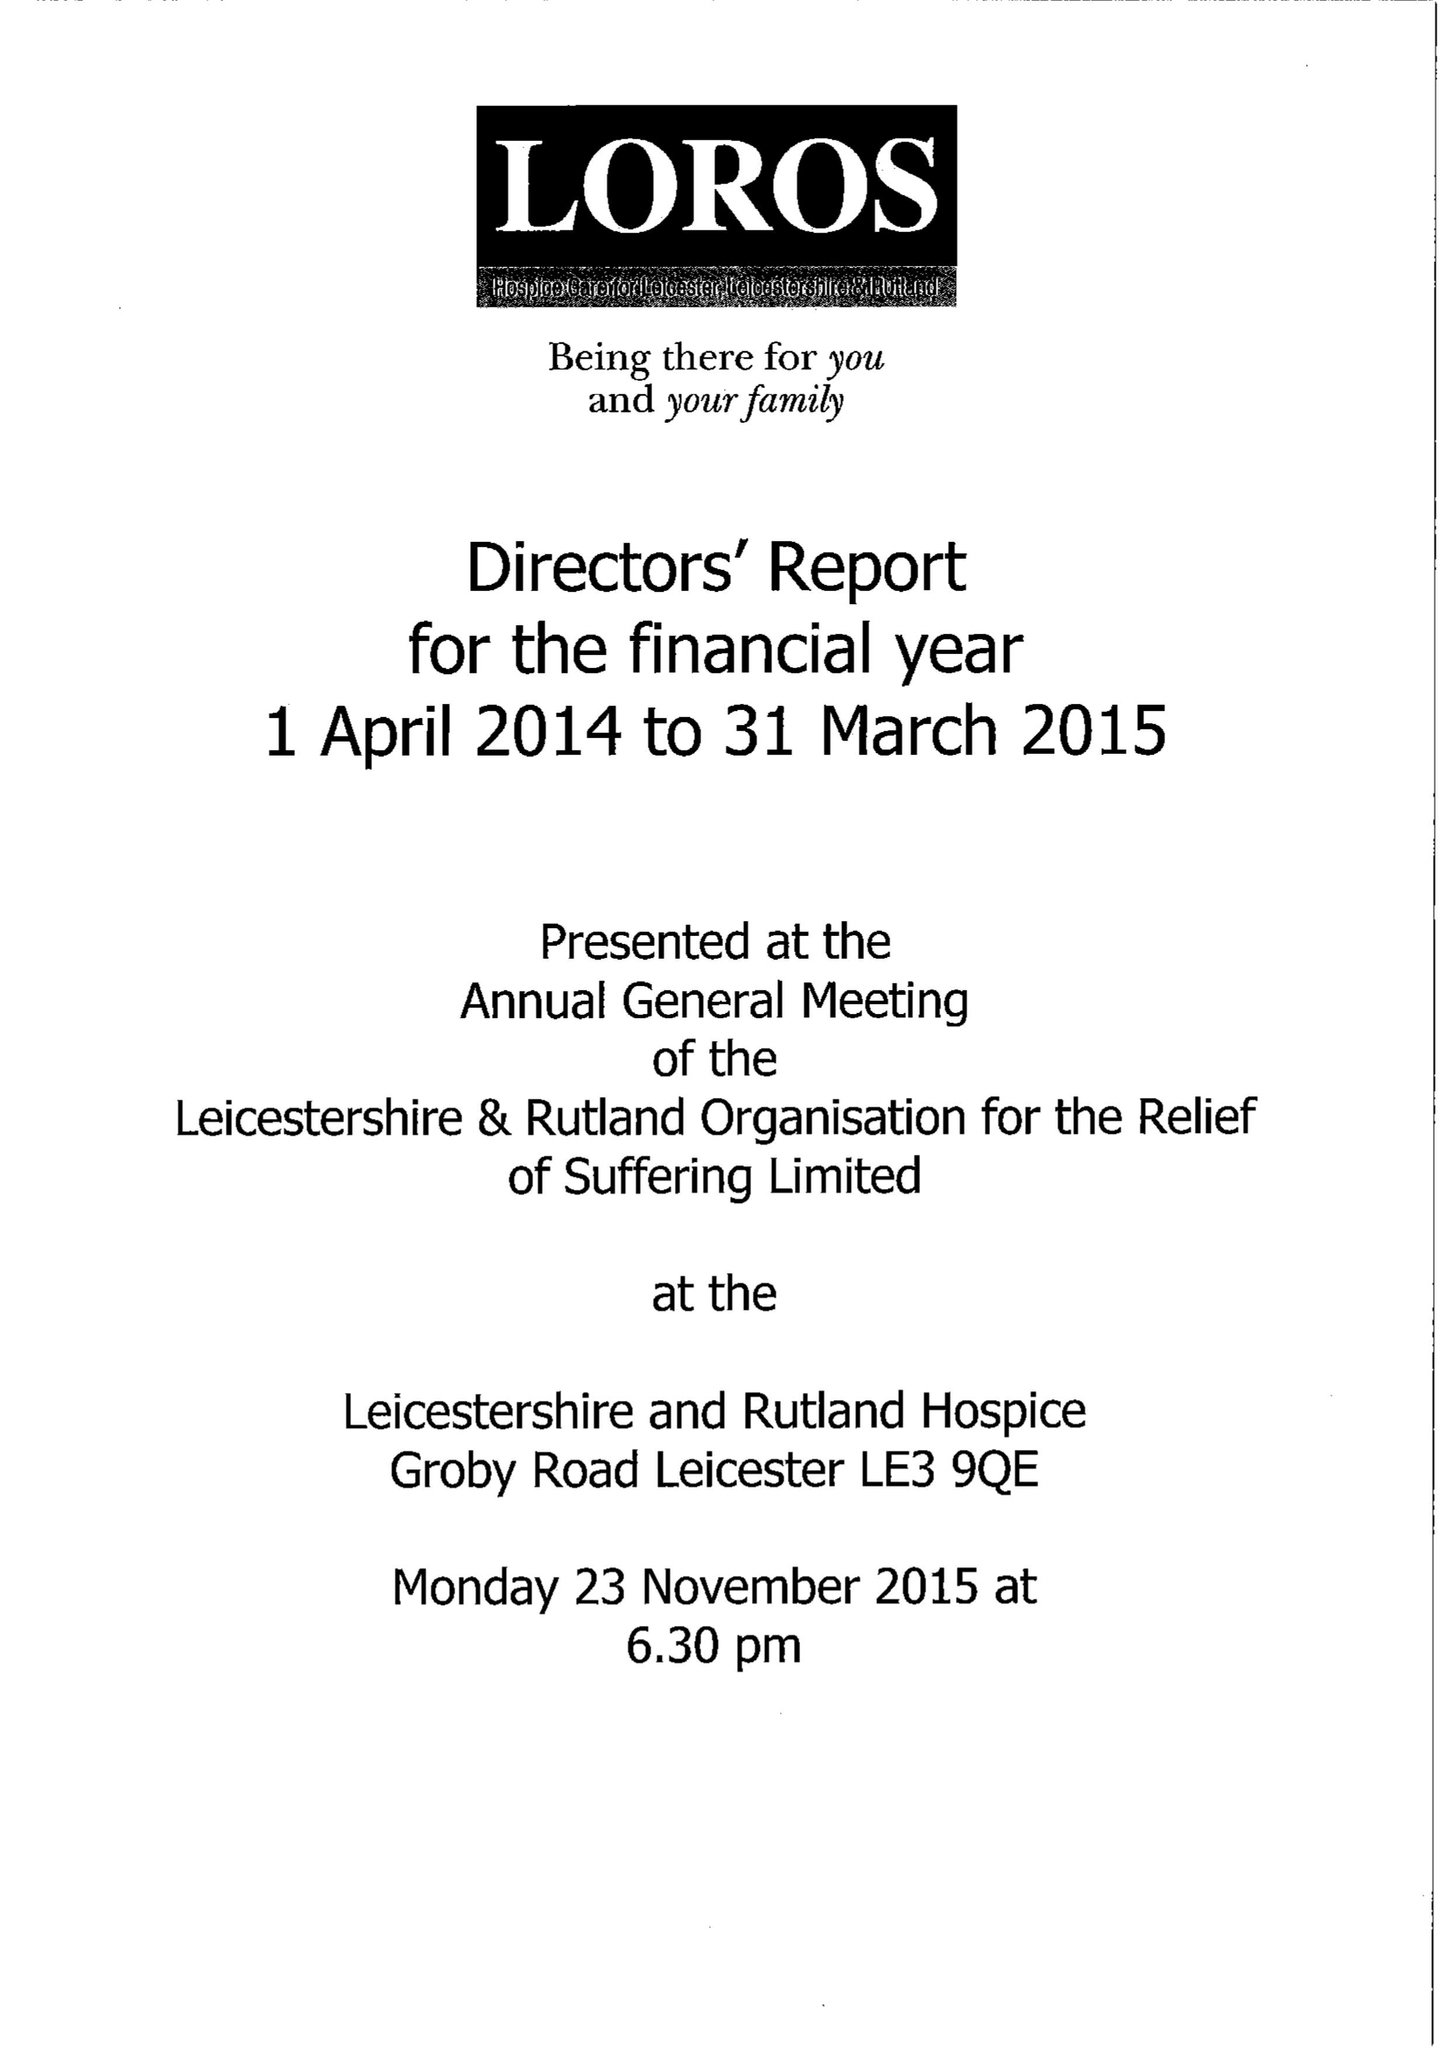What is the value for the address__post_town?
Answer the question using a single word or phrase. LEICESTER 